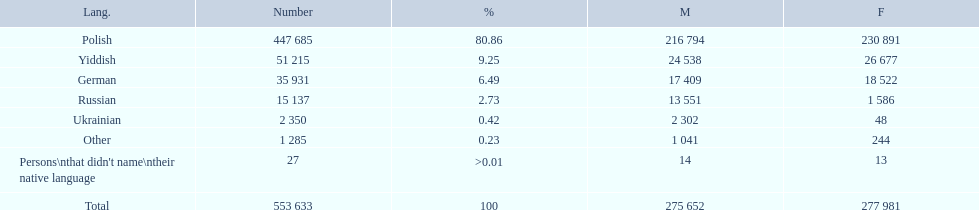What were the languages in plock governorate? Polish, Yiddish, German, Russian, Ukrainian, Other. Which language has a value of .42? Ukrainian. 